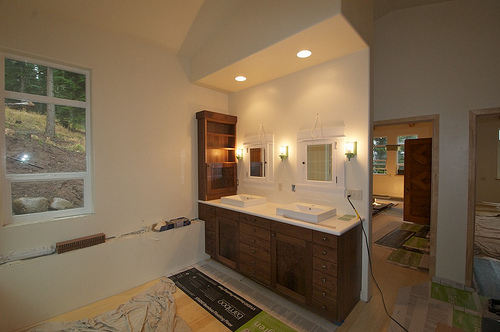<image>
Can you confirm if the tree is behind the window? Yes. From this viewpoint, the tree is positioned behind the window, with the window partially or fully occluding the tree. 